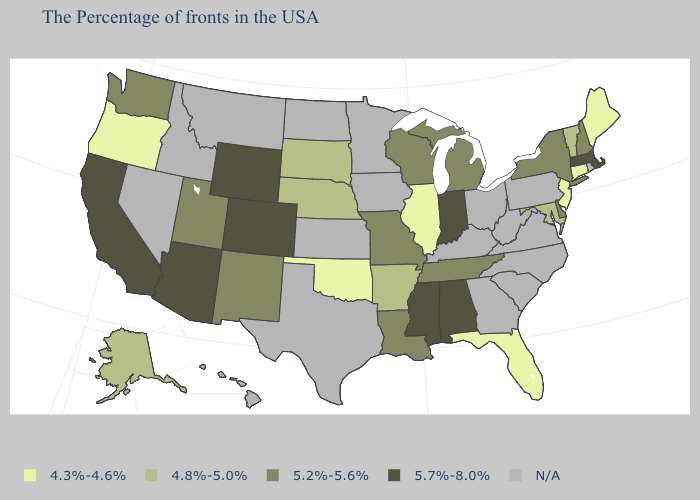What is the highest value in the USA?
Concise answer only. 5.7%-8.0%. Among the states that border Kansas , which have the highest value?
Give a very brief answer. Colorado. Name the states that have a value in the range 5.7%-8.0%?
Write a very short answer. Massachusetts, Indiana, Alabama, Mississippi, Wyoming, Colorado, Arizona, California. How many symbols are there in the legend?
Concise answer only. 5. Does the map have missing data?
Short answer required. Yes. What is the value of Nevada?
Concise answer only. N/A. What is the lowest value in states that border Pennsylvania?
Write a very short answer. 4.3%-4.6%. What is the lowest value in the USA?
Give a very brief answer. 4.3%-4.6%. What is the value of Wyoming?
Keep it brief. 5.7%-8.0%. Does the map have missing data?
Keep it brief. Yes. What is the lowest value in states that border Kentucky?
Answer briefly. 4.3%-4.6%. Name the states that have a value in the range 4.3%-4.6%?
Keep it brief. Maine, Connecticut, New Jersey, Florida, Illinois, Oklahoma, Oregon. What is the lowest value in the USA?
Keep it brief. 4.3%-4.6%. Does Arizona have the highest value in the USA?
Answer briefly. Yes. Does Florida have the highest value in the South?
Answer briefly. No. 